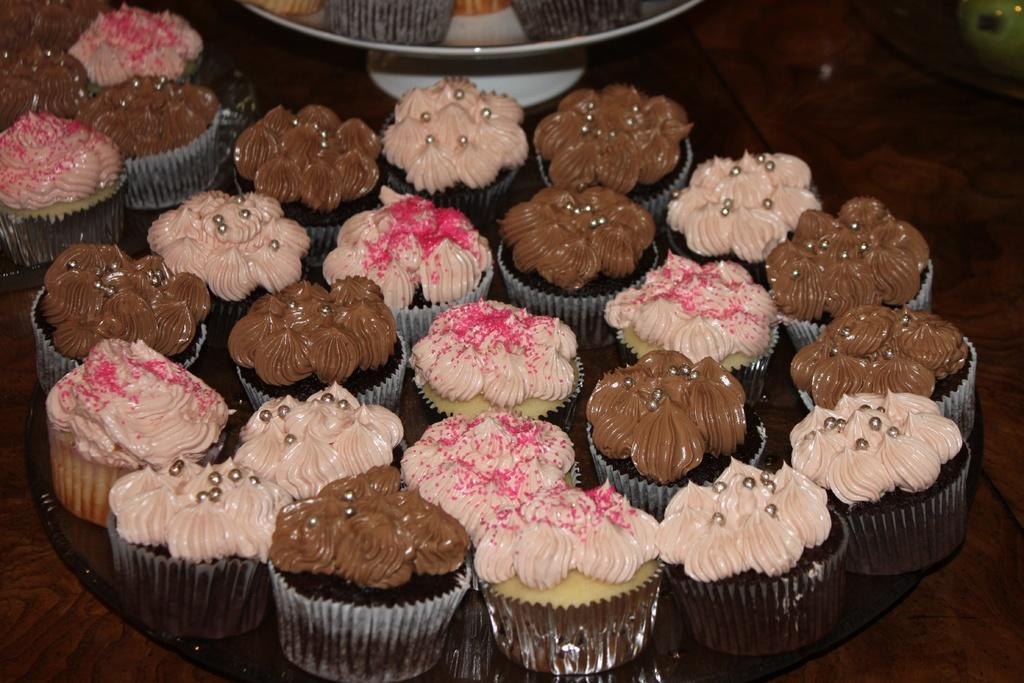What type of food is featured in the image? There is a group of cupcakes in the image. How are the cupcakes arranged or displayed? The cupcakes are on plates. What type of surface are the plates and cupcakes resting on? There is a wooden table in the image. What religious symbols can be seen on the cupcakes in the image? There are no religious symbols present on the cupcakes in the image. How many cats are sitting on the wooden table in the image? There are no cats present in the image; it only features a group of cupcakes on plates. 